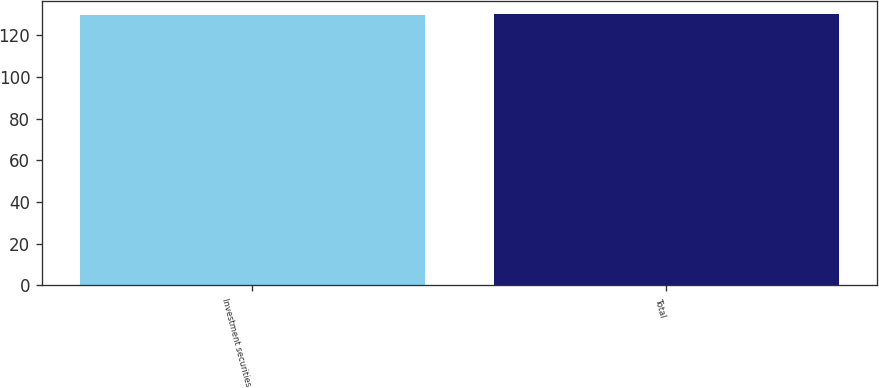<chart> <loc_0><loc_0><loc_500><loc_500><bar_chart><fcel>Investment securities<fcel>Total<nl><fcel>130<fcel>130.1<nl></chart> 